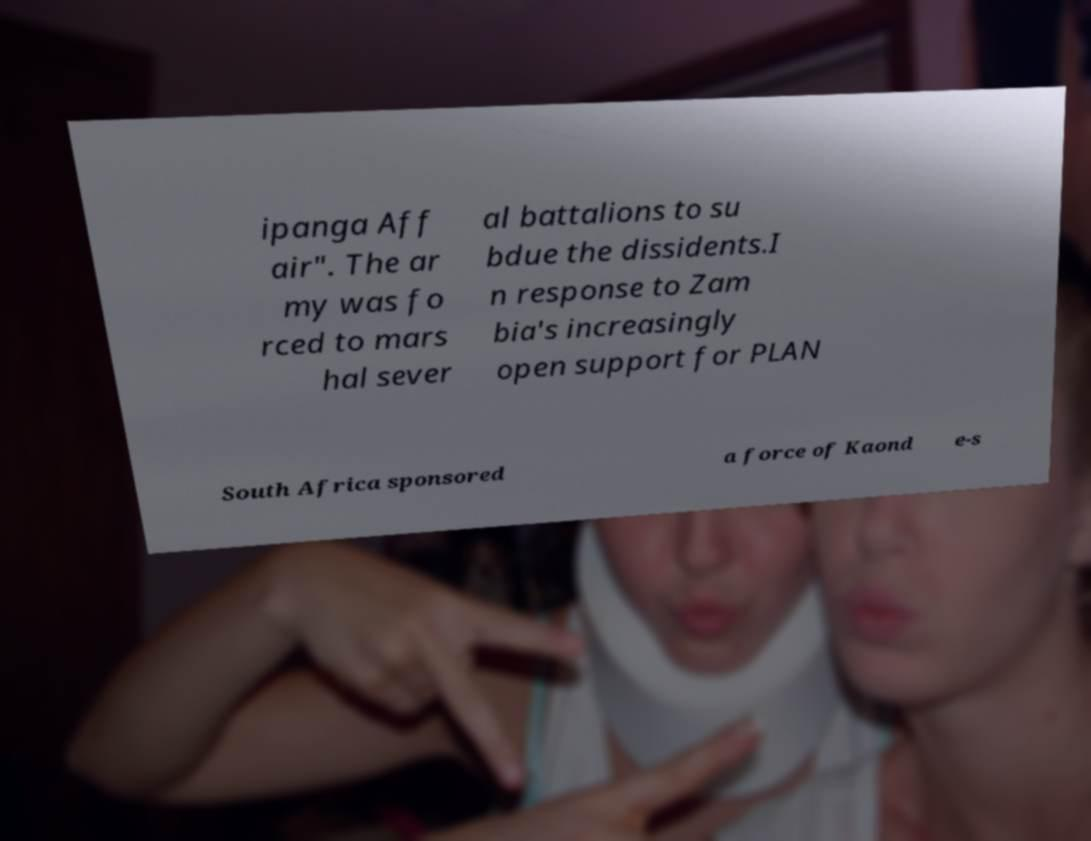Can you accurately transcribe the text from the provided image for me? ipanga Aff air". The ar my was fo rced to mars hal sever al battalions to su bdue the dissidents.I n response to Zam bia's increasingly open support for PLAN South Africa sponsored a force of Kaond e-s 